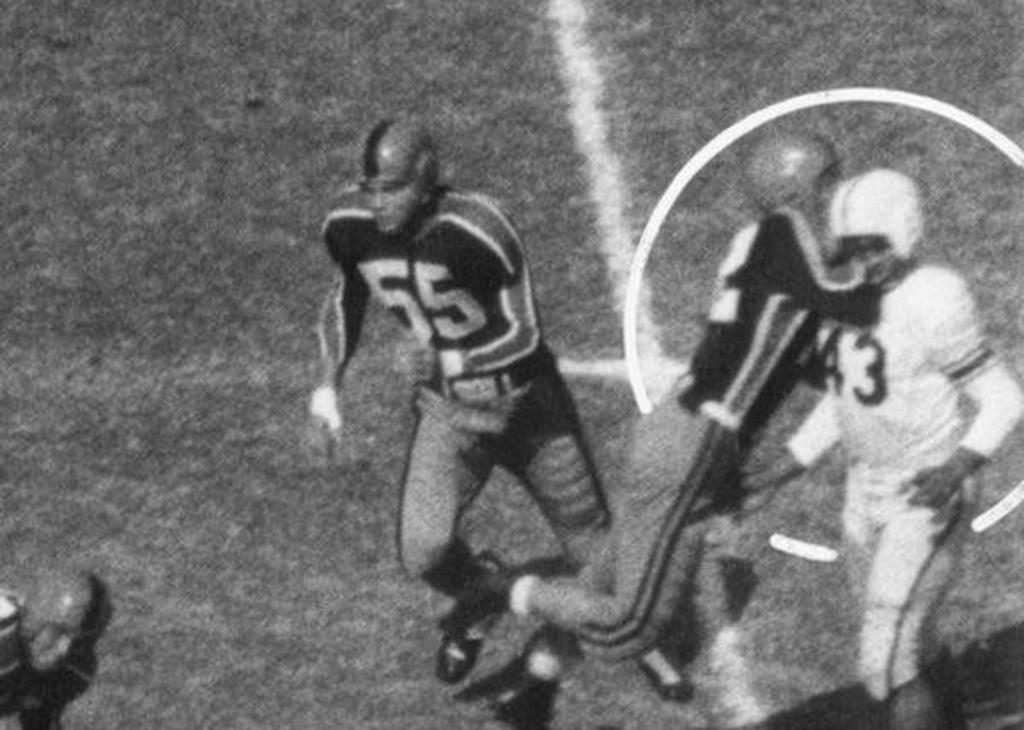What is the color scheme of the image? The image is black and white. Where was the image taken? The image was taken in a playground. How many people are in the image? There are four men in the image. What type of legal advice can be seen being given in the image? There is no lawyer or legal advice present in the image; it is taken in a playground with four men. 